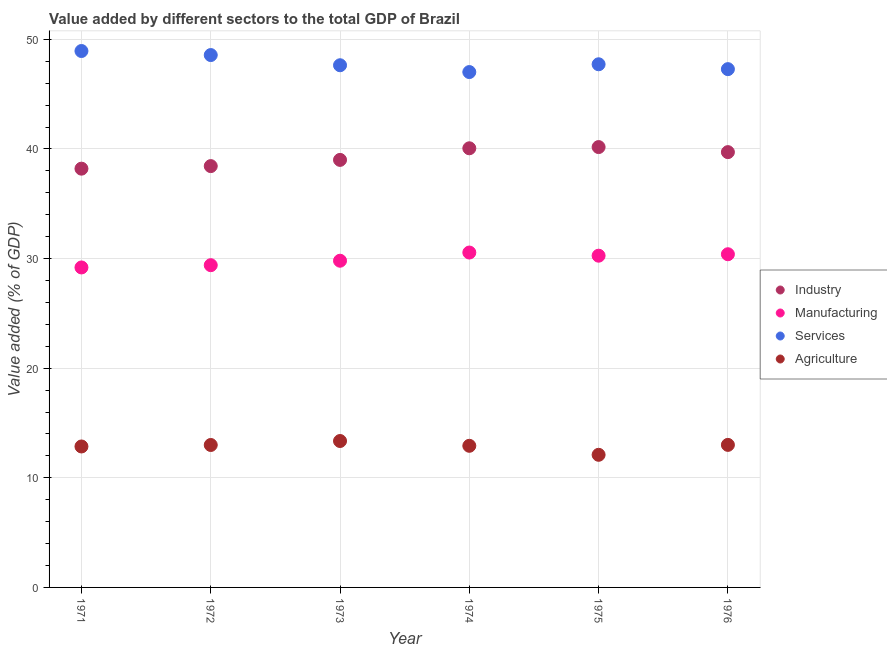How many different coloured dotlines are there?
Your answer should be very brief. 4. What is the value added by industrial sector in 1976?
Your response must be concise. 39.71. Across all years, what is the maximum value added by services sector?
Offer a terse response. 48.94. Across all years, what is the minimum value added by industrial sector?
Provide a short and direct response. 38.2. In which year was the value added by manufacturing sector maximum?
Your answer should be compact. 1974. In which year was the value added by services sector minimum?
Your answer should be very brief. 1974. What is the total value added by manufacturing sector in the graph?
Ensure brevity in your answer.  179.61. What is the difference between the value added by industrial sector in 1971 and that in 1976?
Provide a short and direct response. -1.51. What is the difference between the value added by services sector in 1972 and the value added by industrial sector in 1974?
Offer a very short reply. 8.51. What is the average value added by manufacturing sector per year?
Give a very brief answer. 29.93. In the year 1975, what is the difference between the value added by manufacturing sector and value added by agricultural sector?
Offer a terse response. 18.16. In how many years, is the value added by agricultural sector greater than 18 %?
Provide a short and direct response. 0. What is the ratio of the value added by industrial sector in 1974 to that in 1975?
Provide a succinct answer. 1. Is the value added by agricultural sector in 1971 less than that in 1972?
Provide a succinct answer. Yes. What is the difference between the highest and the second highest value added by industrial sector?
Give a very brief answer. 0.11. What is the difference between the highest and the lowest value added by services sector?
Ensure brevity in your answer.  1.92. Is it the case that in every year, the sum of the value added by agricultural sector and value added by industrial sector is greater than the sum of value added by manufacturing sector and value added by services sector?
Provide a short and direct response. No. Is the value added by services sector strictly less than the value added by manufacturing sector over the years?
Your answer should be very brief. No. How many dotlines are there?
Your response must be concise. 4. How many years are there in the graph?
Keep it short and to the point. 6. Does the graph contain grids?
Offer a very short reply. Yes. What is the title of the graph?
Your answer should be compact. Value added by different sectors to the total GDP of Brazil. Does "Other greenhouse gases" appear as one of the legend labels in the graph?
Offer a terse response. No. What is the label or title of the Y-axis?
Keep it short and to the point. Value added (% of GDP). What is the Value added (% of GDP) of Industry in 1971?
Ensure brevity in your answer.  38.2. What is the Value added (% of GDP) of Manufacturing in 1971?
Offer a very short reply. 29.19. What is the Value added (% of GDP) of Services in 1971?
Your answer should be compact. 48.94. What is the Value added (% of GDP) of Agriculture in 1971?
Your answer should be compact. 12.86. What is the Value added (% of GDP) of Industry in 1972?
Your answer should be very brief. 38.44. What is the Value added (% of GDP) in Manufacturing in 1972?
Provide a succinct answer. 29.4. What is the Value added (% of GDP) in Services in 1972?
Make the answer very short. 48.57. What is the Value added (% of GDP) in Agriculture in 1972?
Your answer should be compact. 12.99. What is the Value added (% of GDP) of Industry in 1973?
Make the answer very short. 39. What is the Value added (% of GDP) of Manufacturing in 1973?
Give a very brief answer. 29.81. What is the Value added (% of GDP) in Services in 1973?
Provide a succinct answer. 47.64. What is the Value added (% of GDP) of Agriculture in 1973?
Provide a succinct answer. 13.36. What is the Value added (% of GDP) of Industry in 1974?
Provide a short and direct response. 40.06. What is the Value added (% of GDP) of Manufacturing in 1974?
Give a very brief answer. 30.55. What is the Value added (% of GDP) in Services in 1974?
Give a very brief answer. 47.02. What is the Value added (% of GDP) in Agriculture in 1974?
Keep it short and to the point. 12.92. What is the Value added (% of GDP) of Industry in 1975?
Give a very brief answer. 40.17. What is the Value added (% of GDP) of Manufacturing in 1975?
Make the answer very short. 30.26. What is the Value added (% of GDP) of Services in 1975?
Give a very brief answer. 47.73. What is the Value added (% of GDP) in Agriculture in 1975?
Provide a succinct answer. 12.1. What is the Value added (% of GDP) of Industry in 1976?
Your response must be concise. 39.71. What is the Value added (% of GDP) of Manufacturing in 1976?
Offer a very short reply. 30.4. What is the Value added (% of GDP) in Services in 1976?
Your answer should be very brief. 47.28. What is the Value added (% of GDP) in Agriculture in 1976?
Ensure brevity in your answer.  13. Across all years, what is the maximum Value added (% of GDP) in Industry?
Provide a succinct answer. 40.17. Across all years, what is the maximum Value added (% of GDP) in Manufacturing?
Give a very brief answer. 30.55. Across all years, what is the maximum Value added (% of GDP) of Services?
Provide a short and direct response. 48.94. Across all years, what is the maximum Value added (% of GDP) in Agriculture?
Your answer should be very brief. 13.36. Across all years, what is the minimum Value added (% of GDP) in Industry?
Keep it short and to the point. 38.2. Across all years, what is the minimum Value added (% of GDP) of Manufacturing?
Your response must be concise. 29.19. Across all years, what is the minimum Value added (% of GDP) in Services?
Your response must be concise. 47.02. Across all years, what is the minimum Value added (% of GDP) in Agriculture?
Offer a very short reply. 12.1. What is the total Value added (% of GDP) of Industry in the graph?
Your answer should be compact. 235.59. What is the total Value added (% of GDP) in Manufacturing in the graph?
Give a very brief answer. 179.61. What is the total Value added (% of GDP) of Services in the graph?
Provide a succinct answer. 287.17. What is the total Value added (% of GDP) of Agriculture in the graph?
Give a very brief answer. 77.23. What is the difference between the Value added (% of GDP) of Industry in 1971 and that in 1972?
Keep it short and to the point. -0.23. What is the difference between the Value added (% of GDP) in Manufacturing in 1971 and that in 1972?
Your answer should be very brief. -0.21. What is the difference between the Value added (% of GDP) in Services in 1971 and that in 1972?
Your answer should be compact. 0.37. What is the difference between the Value added (% of GDP) of Agriculture in 1971 and that in 1972?
Provide a succinct answer. -0.14. What is the difference between the Value added (% of GDP) of Industry in 1971 and that in 1973?
Give a very brief answer. -0.8. What is the difference between the Value added (% of GDP) of Manufacturing in 1971 and that in 1973?
Your response must be concise. -0.61. What is the difference between the Value added (% of GDP) in Services in 1971 and that in 1973?
Your response must be concise. 1.3. What is the difference between the Value added (% of GDP) of Agriculture in 1971 and that in 1973?
Your response must be concise. -0.5. What is the difference between the Value added (% of GDP) of Industry in 1971 and that in 1974?
Your response must be concise. -1.86. What is the difference between the Value added (% of GDP) of Manufacturing in 1971 and that in 1974?
Keep it short and to the point. -1.36. What is the difference between the Value added (% of GDP) in Services in 1971 and that in 1974?
Provide a succinct answer. 1.92. What is the difference between the Value added (% of GDP) of Agriculture in 1971 and that in 1974?
Your answer should be compact. -0.06. What is the difference between the Value added (% of GDP) of Industry in 1971 and that in 1975?
Offer a terse response. -1.97. What is the difference between the Value added (% of GDP) in Manufacturing in 1971 and that in 1975?
Provide a succinct answer. -1.07. What is the difference between the Value added (% of GDP) of Services in 1971 and that in 1975?
Make the answer very short. 1.21. What is the difference between the Value added (% of GDP) in Agriculture in 1971 and that in 1975?
Ensure brevity in your answer.  0.76. What is the difference between the Value added (% of GDP) of Industry in 1971 and that in 1976?
Provide a short and direct response. -1.51. What is the difference between the Value added (% of GDP) in Manufacturing in 1971 and that in 1976?
Give a very brief answer. -1.21. What is the difference between the Value added (% of GDP) in Services in 1971 and that in 1976?
Your response must be concise. 1.65. What is the difference between the Value added (% of GDP) in Agriculture in 1971 and that in 1976?
Provide a short and direct response. -0.15. What is the difference between the Value added (% of GDP) of Industry in 1972 and that in 1973?
Provide a succinct answer. -0.57. What is the difference between the Value added (% of GDP) in Manufacturing in 1972 and that in 1973?
Ensure brevity in your answer.  -0.41. What is the difference between the Value added (% of GDP) of Services in 1972 and that in 1973?
Provide a succinct answer. 0.93. What is the difference between the Value added (% of GDP) in Agriculture in 1972 and that in 1973?
Your response must be concise. -0.36. What is the difference between the Value added (% of GDP) in Industry in 1972 and that in 1974?
Provide a succinct answer. -1.63. What is the difference between the Value added (% of GDP) of Manufacturing in 1972 and that in 1974?
Give a very brief answer. -1.15. What is the difference between the Value added (% of GDP) in Services in 1972 and that in 1974?
Offer a terse response. 1.55. What is the difference between the Value added (% of GDP) of Agriculture in 1972 and that in 1974?
Keep it short and to the point. 0.07. What is the difference between the Value added (% of GDP) of Industry in 1972 and that in 1975?
Ensure brevity in your answer.  -1.74. What is the difference between the Value added (% of GDP) of Manufacturing in 1972 and that in 1975?
Your answer should be compact. -0.87. What is the difference between the Value added (% of GDP) in Services in 1972 and that in 1975?
Provide a succinct answer. 0.84. What is the difference between the Value added (% of GDP) in Agriculture in 1972 and that in 1975?
Ensure brevity in your answer.  0.9. What is the difference between the Value added (% of GDP) in Industry in 1972 and that in 1976?
Your answer should be compact. -1.27. What is the difference between the Value added (% of GDP) in Manufacturing in 1972 and that in 1976?
Offer a terse response. -1. What is the difference between the Value added (% of GDP) of Services in 1972 and that in 1976?
Your answer should be compact. 1.28. What is the difference between the Value added (% of GDP) in Agriculture in 1972 and that in 1976?
Your answer should be very brief. -0.01. What is the difference between the Value added (% of GDP) of Industry in 1973 and that in 1974?
Provide a short and direct response. -1.06. What is the difference between the Value added (% of GDP) in Manufacturing in 1973 and that in 1974?
Your answer should be very brief. -0.75. What is the difference between the Value added (% of GDP) in Services in 1973 and that in 1974?
Offer a very short reply. 0.62. What is the difference between the Value added (% of GDP) in Agriculture in 1973 and that in 1974?
Give a very brief answer. 0.44. What is the difference between the Value added (% of GDP) in Industry in 1973 and that in 1975?
Provide a short and direct response. -1.17. What is the difference between the Value added (% of GDP) in Manufacturing in 1973 and that in 1975?
Your response must be concise. -0.46. What is the difference between the Value added (% of GDP) of Services in 1973 and that in 1975?
Make the answer very short. -0.09. What is the difference between the Value added (% of GDP) in Agriculture in 1973 and that in 1975?
Make the answer very short. 1.26. What is the difference between the Value added (% of GDP) in Industry in 1973 and that in 1976?
Give a very brief answer. -0.71. What is the difference between the Value added (% of GDP) of Manufacturing in 1973 and that in 1976?
Give a very brief answer. -0.59. What is the difference between the Value added (% of GDP) in Services in 1973 and that in 1976?
Make the answer very short. 0.36. What is the difference between the Value added (% of GDP) in Agriculture in 1973 and that in 1976?
Provide a succinct answer. 0.35. What is the difference between the Value added (% of GDP) of Industry in 1974 and that in 1975?
Make the answer very short. -0.11. What is the difference between the Value added (% of GDP) of Manufacturing in 1974 and that in 1975?
Keep it short and to the point. 0.29. What is the difference between the Value added (% of GDP) of Services in 1974 and that in 1975?
Ensure brevity in your answer.  -0.71. What is the difference between the Value added (% of GDP) of Agriculture in 1974 and that in 1975?
Keep it short and to the point. 0.82. What is the difference between the Value added (% of GDP) in Industry in 1974 and that in 1976?
Give a very brief answer. 0.35. What is the difference between the Value added (% of GDP) of Manufacturing in 1974 and that in 1976?
Your response must be concise. 0.16. What is the difference between the Value added (% of GDP) in Services in 1974 and that in 1976?
Offer a very short reply. -0.27. What is the difference between the Value added (% of GDP) in Agriculture in 1974 and that in 1976?
Your answer should be very brief. -0.08. What is the difference between the Value added (% of GDP) of Industry in 1975 and that in 1976?
Make the answer very short. 0.46. What is the difference between the Value added (% of GDP) of Manufacturing in 1975 and that in 1976?
Keep it short and to the point. -0.13. What is the difference between the Value added (% of GDP) of Services in 1975 and that in 1976?
Your response must be concise. 0.44. What is the difference between the Value added (% of GDP) in Agriculture in 1975 and that in 1976?
Your answer should be very brief. -0.91. What is the difference between the Value added (% of GDP) of Industry in 1971 and the Value added (% of GDP) of Manufacturing in 1972?
Your answer should be compact. 8.81. What is the difference between the Value added (% of GDP) of Industry in 1971 and the Value added (% of GDP) of Services in 1972?
Keep it short and to the point. -10.36. What is the difference between the Value added (% of GDP) in Industry in 1971 and the Value added (% of GDP) in Agriculture in 1972?
Provide a short and direct response. 25.21. What is the difference between the Value added (% of GDP) in Manufacturing in 1971 and the Value added (% of GDP) in Services in 1972?
Provide a short and direct response. -19.38. What is the difference between the Value added (% of GDP) of Manufacturing in 1971 and the Value added (% of GDP) of Agriculture in 1972?
Ensure brevity in your answer.  16.2. What is the difference between the Value added (% of GDP) of Services in 1971 and the Value added (% of GDP) of Agriculture in 1972?
Ensure brevity in your answer.  35.94. What is the difference between the Value added (% of GDP) in Industry in 1971 and the Value added (% of GDP) in Manufacturing in 1973?
Provide a short and direct response. 8.4. What is the difference between the Value added (% of GDP) in Industry in 1971 and the Value added (% of GDP) in Services in 1973?
Offer a very short reply. -9.43. What is the difference between the Value added (% of GDP) of Industry in 1971 and the Value added (% of GDP) of Agriculture in 1973?
Ensure brevity in your answer.  24.85. What is the difference between the Value added (% of GDP) in Manufacturing in 1971 and the Value added (% of GDP) in Services in 1973?
Offer a terse response. -18.45. What is the difference between the Value added (% of GDP) in Manufacturing in 1971 and the Value added (% of GDP) in Agriculture in 1973?
Provide a short and direct response. 15.83. What is the difference between the Value added (% of GDP) of Services in 1971 and the Value added (% of GDP) of Agriculture in 1973?
Provide a succinct answer. 35.58. What is the difference between the Value added (% of GDP) in Industry in 1971 and the Value added (% of GDP) in Manufacturing in 1974?
Keep it short and to the point. 7.65. What is the difference between the Value added (% of GDP) of Industry in 1971 and the Value added (% of GDP) of Services in 1974?
Make the answer very short. -8.81. What is the difference between the Value added (% of GDP) in Industry in 1971 and the Value added (% of GDP) in Agriculture in 1974?
Your answer should be compact. 25.28. What is the difference between the Value added (% of GDP) of Manufacturing in 1971 and the Value added (% of GDP) of Services in 1974?
Give a very brief answer. -17.83. What is the difference between the Value added (% of GDP) of Manufacturing in 1971 and the Value added (% of GDP) of Agriculture in 1974?
Offer a very short reply. 16.27. What is the difference between the Value added (% of GDP) of Services in 1971 and the Value added (% of GDP) of Agriculture in 1974?
Offer a very short reply. 36.02. What is the difference between the Value added (% of GDP) in Industry in 1971 and the Value added (% of GDP) in Manufacturing in 1975?
Offer a terse response. 7.94. What is the difference between the Value added (% of GDP) in Industry in 1971 and the Value added (% of GDP) in Services in 1975?
Offer a terse response. -9.52. What is the difference between the Value added (% of GDP) of Industry in 1971 and the Value added (% of GDP) of Agriculture in 1975?
Offer a very short reply. 26.1. What is the difference between the Value added (% of GDP) in Manufacturing in 1971 and the Value added (% of GDP) in Services in 1975?
Offer a terse response. -18.54. What is the difference between the Value added (% of GDP) of Manufacturing in 1971 and the Value added (% of GDP) of Agriculture in 1975?
Keep it short and to the point. 17.09. What is the difference between the Value added (% of GDP) of Services in 1971 and the Value added (% of GDP) of Agriculture in 1975?
Offer a very short reply. 36.84. What is the difference between the Value added (% of GDP) in Industry in 1971 and the Value added (% of GDP) in Manufacturing in 1976?
Give a very brief answer. 7.81. What is the difference between the Value added (% of GDP) of Industry in 1971 and the Value added (% of GDP) of Services in 1976?
Your answer should be very brief. -9.08. What is the difference between the Value added (% of GDP) of Industry in 1971 and the Value added (% of GDP) of Agriculture in 1976?
Keep it short and to the point. 25.2. What is the difference between the Value added (% of GDP) in Manufacturing in 1971 and the Value added (% of GDP) in Services in 1976?
Your answer should be compact. -18.09. What is the difference between the Value added (% of GDP) of Manufacturing in 1971 and the Value added (% of GDP) of Agriculture in 1976?
Offer a very short reply. 16.19. What is the difference between the Value added (% of GDP) in Services in 1971 and the Value added (% of GDP) in Agriculture in 1976?
Your response must be concise. 35.93. What is the difference between the Value added (% of GDP) in Industry in 1972 and the Value added (% of GDP) in Manufacturing in 1973?
Provide a succinct answer. 8.63. What is the difference between the Value added (% of GDP) of Industry in 1972 and the Value added (% of GDP) of Services in 1973?
Your answer should be very brief. -9.2. What is the difference between the Value added (% of GDP) in Industry in 1972 and the Value added (% of GDP) in Agriculture in 1973?
Your answer should be compact. 25.08. What is the difference between the Value added (% of GDP) in Manufacturing in 1972 and the Value added (% of GDP) in Services in 1973?
Your answer should be very brief. -18.24. What is the difference between the Value added (% of GDP) in Manufacturing in 1972 and the Value added (% of GDP) in Agriculture in 1973?
Provide a short and direct response. 16.04. What is the difference between the Value added (% of GDP) of Services in 1972 and the Value added (% of GDP) of Agriculture in 1973?
Your answer should be compact. 35.21. What is the difference between the Value added (% of GDP) of Industry in 1972 and the Value added (% of GDP) of Manufacturing in 1974?
Make the answer very short. 7.88. What is the difference between the Value added (% of GDP) in Industry in 1972 and the Value added (% of GDP) in Services in 1974?
Offer a terse response. -8.58. What is the difference between the Value added (% of GDP) of Industry in 1972 and the Value added (% of GDP) of Agriculture in 1974?
Your response must be concise. 25.52. What is the difference between the Value added (% of GDP) in Manufacturing in 1972 and the Value added (% of GDP) in Services in 1974?
Keep it short and to the point. -17.62. What is the difference between the Value added (% of GDP) of Manufacturing in 1972 and the Value added (% of GDP) of Agriculture in 1974?
Ensure brevity in your answer.  16.48. What is the difference between the Value added (% of GDP) in Services in 1972 and the Value added (% of GDP) in Agriculture in 1974?
Offer a very short reply. 35.65. What is the difference between the Value added (% of GDP) in Industry in 1972 and the Value added (% of GDP) in Manufacturing in 1975?
Make the answer very short. 8.17. What is the difference between the Value added (% of GDP) in Industry in 1972 and the Value added (% of GDP) in Services in 1975?
Give a very brief answer. -9.29. What is the difference between the Value added (% of GDP) of Industry in 1972 and the Value added (% of GDP) of Agriculture in 1975?
Provide a succinct answer. 26.34. What is the difference between the Value added (% of GDP) in Manufacturing in 1972 and the Value added (% of GDP) in Services in 1975?
Your answer should be very brief. -18.33. What is the difference between the Value added (% of GDP) in Manufacturing in 1972 and the Value added (% of GDP) in Agriculture in 1975?
Give a very brief answer. 17.3. What is the difference between the Value added (% of GDP) in Services in 1972 and the Value added (% of GDP) in Agriculture in 1975?
Provide a succinct answer. 36.47. What is the difference between the Value added (% of GDP) in Industry in 1972 and the Value added (% of GDP) in Manufacturing in 1976?
Provide a succinct answer. 8.04. What is the difference between the Value added (% of GDP) in Industry in 1972 and the Value added (% of GDP) in Services in 1976?
Provide a short and direct response. -8.85. What is the difference between the Value added (% of GDP) in Industry in 1972 and the Value added (% of GDP) in Agriculture in 1976?
Your response must be concise. 25.43. What is the difference between the Value added (% of GDP) in Manufacturing in 1972 and the Value added (% of GDP) in Services in 1976?
Keep it short and to the point. -17.89. What is the difference between the Value added (% of GDP) of Manufacturing in 1972 and the Value added (% of GDP) of Agriculture in 1976?
Make the answer very short. 16.39. What is the difference between the Value added (% of GDP) in Services in 1972 and the Value added (% of GDP) in Agriculture in 1976?
Provide a succinct answer. 35.56. What is the difference between the Value added (% of GDP) of Industry in 1973 and the Value added (% of GDP) of Manufacturing in 1974?
Offer a very short reply. 8.45. What is the difference between the Value added (% of GDP) in Industry in 1973 and the Value added (% of GDP) in Services in 1974?
Offer a terse response. -8.01. What is the difference between the Value added (% of GDP) in Industry in 1973 and the Value added (% of GDP) in Agriculture in 1974?
Your answer should be very brief. 26.08. What is the difference between the Value added (% of GDP) of Manufacturing in 1973 and the Value added (% of GDP) of Services in 1974?
Your answer should be very brief. -17.21. What is the difference between the Value added (% of GDP) in Manufacturing in 1973 and the Value added (% of GDP) in Agriculture in 1974?
Your answer should be very brief. 16.88. What is the difference between the Value added (% of GDP) of Services in 1973 and the Value added (% of GDP) of Agriculture in 1974?
Offer a very short reply. 34.72. What is the difference between the Value added (% of GDP) of Industry in 1973 and the Value added (% of GDP) of Manufacturing in 1975?
Make the answer very short. 8.74. What is the difference between the Value added (% of GDP) in Industry in 1973 and the Value added (% of GDP) in Services in 1975?
Your response must be concise. -8.72. What is the difference between the Value added (% of GDP) in Industry in 1973 and the Value added (% of GDP) in Agriculture in 1975?
Your response must be concise. 26.91. What is the difference between the Value added (% of GDP) of Manufacturing in 1973 and the Value added (% of GDP) of Services in 1975?
Your response must be concise. -17.92. What is the difference between the Value added (% of GDP) of Manufacturing in 1973 and the Value added (% of GDP) of Agriculture in 1975?
Ensure brevity in your answer.  17.71. What is the difference between the Value added (% of GDP) of Services in 1973 and the Value added (% of GDP) of Agriculture in 1975?
Offer a terse response. 35.54. What is the difference between the Value added (% of GDP) of Industry in 1973 and the Value added (% of GDP) of Manufacturing in 1976?
Keep it short and to the point. 8.61. What is the difference between the Value added (% of GDP) in Industry in 1973 and the Value added (% of GDP) in Services in 1976?
Provide a short and direct response. -8.28. What is the difference between the Value added (% of GDP) in Industry in 1973 and the Value added (% of GDP) in Agriculture in 1976?
Offer a very short reply. 26. What is the difference between the Value added (% of GDP) of Manufacturing in 1973 and the Value added (% of GDP) of Services in 1976?
Ensure brevity in your answer.  -17.48. What is the difference between the Value added (% of GDP) in Manufacturing in 1973 and the Value added (% of GDP) in Agriculture in 1976?
Your answer should be compact. 16.8. What is the difference between the Value added (% of GDP) of Services in 1973 and the Value added (% of GDP) of Agriculture in 1976?
Make the answer very short. 34.63. What is the difference between the Value added (% of GDP) in Industry in 1974 and the Value added (% of GDP) in Manufacturing in 1975?
Make the answer very short. 9.8. What is the difference between the Value added (% of GDP) in Industry in 1974 and the Value added (% of GDP) in Services in 1975?
Give a very brief answer. -7.66. What is the difference between the Value added (% of GDP) of Industry in 1974 and the Value added (% of GDP) of Agriculture in 1975?
Your response must be concise. 27.96. What is the difference between the Value added (% of GDP) in Manufacturing in 1974 and the Value added (% of GDP) in Services in 1975?
Offer a very short reply. -17.18. What is the difference between the Value added (% of GDP) of Manufacturing in 1974 and the Value added (% of GDP) of Agriculture in 1975?
Your response must be concise. 18.45. What is the difference between the Value added (% of GDP) of Services in 1974 and the Value added (% of GDP) of Agriculture in 1975?
Provide a short and direct response. 34.92. What is the difference between the Value added (% of GDP) in Industry in 1974 and the Value added (% of GDP) in Manufacturing in 1976?
Make the answer very short. 9.67. What is the difference between the Value added (% of GDP) of Industry in 1974 and the Value added (% of GDP) of Services in 1976?
Keep it short and to the point. -7.22. What is the difference between the Value added (% of GDP) of Industry in 1974 and the Value added (% of GDP) of Agriculture in 1976?
Your answer should be very brief. 27.06. What is the difference between the Value added (% of GDP) in Manufacturing in 1974 and the Value added (% of GDP) in Services in 1976?
Provide a succinct answer. -16.73. What is the difference between the Value added (% of GDP) in Manufacturing in 1974 and the Value added (% of GDP) in Agriculture in 1976?
Make the answer very short. 17.55. What is the difference between the Value added (% of GDP) of Services in 1974 and the Value added (% of GDP) of Agriculture in 1976?
Keep it short and to the point. 34.01. What is the difference between the Value added (% of GDP) in Industry in 1975 and the Value added (% of GDP) in Manufacturing in 1976?
Give a very brief answer. 9.78. What is the difference between the Value added (% of GDP) of Industry in 1975 and the Value added (% of GDP) of Services in 1976?
Your answer should be very brief. -7.11. What is the difference between the Value added (% of GDP) of Industry in 1975 and the Value added (% of GDP) of Agriculture in 1976?
Keep it short and to the point. 27.17. What is the difference between the Value added (% of GDP) of Manufacturing in 1975 and the Value added (% of GDP) of Services in 1976?
Your answer should be compact. -17.02. What is the difference between the Value added (% of GDP) in Manufacturing in 1975 and the Value added (% of GDP) in Agriculture in 1976?
Your answer should be very brief. 17.26. What is the difference between the Value added (% of GDP) of Services in 1975 and the Value added (% of GDP) of Agriculture in 1976?
Your answer should be very brief. 34.72. What is the average Value added (% of GDP) of Industry per year?
Provide a succinct answer. 39.27. What is the average Value added (% of GDP) in Manufacturing per year?
Keep it short and to the point. 29.93. What is the average Value added (% of GDP) of Services per year?
Your answer should be compact. 47.86. What is the average Value added (% of GDP) of Agriculture per year?
Your answer should be compact. 12.87. In the year 1971, what is the difference between the Value added (% of GDP) in Industry and Value added (% of GDP) in Manufacturing?
Give a very brief answer. 9.01. In the year 1971, what is the difference between the Value added (% of GDP) of Industry and Value added (% of GDP) of Services?
Your answer should be compact. -10.73. In the year 1971, what is the difference between the Value added (% of GDP) in Industry and Value added (% of GDP) in Agriculture?
Offer a terse response. 25.34. In the year 1971, what is the difference between the Value added (% of GDP) in Manufacturing and Value added (% of GDP) in Services?
Your answer should be very brief. -19.75. In the year 1971, what is the difference between the Value added (% of GDP) in Manufacturing and Value added (% of GDP) in Agriculture?
Give a very brief answer. 16.33. In the year 1971, what is the difference between the Value added (% of GDP) of Services and Value added (% of GDP) of Agriculture?
Offer a very short reply. 36.08. In the year 1972, what is the difference between the Value added (% of GDP) of Industry and Value added (% of GDP) of Manufacturing?
Keep it short and to the point. 9.04. In the year 1972, what is the difference between the Value added (% of GDP) in Industry and Value added (% of GDP) in Services?
Offer a terse response. -10.13. In the year 1972, what is the difference between the Value added (% of GDP) of Industry and Value added (% of GDP) of Agriculture?
Your response must be concise. 25.44. In the year 1972, what is the difference between the Value added (% of GDP) of Manufacturing and Value added (% of GDP) of Services?
Give a very brief answer. -19.17. In the year 1972, what is the difference between the Value added (% of GDP) of Manufacturing and Value added (% of GDP) of Agriculture?
Offer a terse response. 16.4. In the year 1972, what is the difference between the Value added (% of GDP) of Services and Value added (% of GDP) of Agriculture?
Make the answer very short. 35.57. In the year 1973, what is the difference between the Value added (% of GDP) of Industry and Value added (% of GDP) of Manufacturing?
Give a very brief answer. 9.2. In the year 1973, what is the difference between the Value added (% of GDP) of Industry and Value added (% of GDP) of Services?
Your response must be concise. -8.63. In the year 1973, what is the difference between the Value added (% of GDP) in Industry and Value added (% of GDP) in Agriculture?
Offer a very short reply. 25.65. In the year 1973, what is the difference between the Value added (% of GDP) of Manufacturing and Value added (% of GDP) of Services?
Keep it short and to the point. -17.83. In the year 1973, what is the difference between the Value added (% of GDP) in Manufacturing and Value added (% of GDP) in Agriculture?
Provide a succinct answer. 16.45. In the year 1973, what is the difference between the Value added (% of GDP) in Services and Value added (% of GDP) in Agriculture?
Offer a very short reply. 34.28. In the year 1974, what is the difference between the Value added (% of GDP) of Industry and Value added (% of GDP) of Manufacturing?
Your answer should be very brief. 9.51. In the year 1974, what is the difference between the Value added (% of GDP) in Industry and Value added (% of GDP) in Services?
Provide a short and direct response. -6.95. In the year 1974, what is the difference between the Value added (% of GDP) of Industry and Value added (% of GDP) of Agriculture?
Offer a very short reply. 27.14. In the year 1974, what is the difference between the Value added (% of GDP) in Manufacturing and Value added (% of GDP) in Services?
Give a very brief answer. -16.46. In the year 1974, what is the difference between the Value added (% of GDP) of Manufacturing and Value added (% of GDP) of Agriculture?
Provide a succinct answer. 17.63. In the year 1974, what is the difference between the Value added (% of GDP) in Services and Value added (% of GDP) in Agriculture?
Offer a terse response. 34.1. In the year 1975, what is the difference between the Value added (% of GDP) in Industry and Value added (% of GDP) in Manufacturing?
Provide a short and direct response. 9.91. In the year 1975, what is the difference between the Value added (% of GDP) in Industry and Value added (% of GDP) in Services?
Your answer should be compact. -7.55. In the year 1975, what is the difference between the Value added (% of GDP) in Industry and Value added (% of GDP) in Agriculture?
Ensure brevity in your answer.  28.07. In the year 1975, what is the difference between the Value added (% of GDP) in Manufacturing and Value added (% of GDP) in Services?
Offer a terse response. -17.46. In the year 1975, what is the difference between the Value added (% of GDP) in Manufacturing and Value added (% of GDP) in Agriculture?
Your answer should be compact. 18.16. In the year 1975, what is the difference between the Value added (% of GDP) in Services and Value added (% of GDP) in Agriculture?
Offer a terse response. 35.63. In the year 1976, what is the difference between the Value added (% of GDP) in Industry and Value added (% of GDP) in Manufacturing?
Your answer should be very brief. 9.32. In the year 1976, what is the difference between the Value added (% of GDP) in Industry and Value added (% of GDP) in Services?
Provide a short and direct response. -7.57. In the year 1976, what is the difference between the Value added (% of GDP) in Industry and Value added (% of GDP) in Agriculture?
Offer a terse response. 26.71. In the year 1976, what is the difference between the Value added (% of GDP) of Manufacturing and Value added (% of GDP) of Services?
Keep it short and to the point. -16.89. In the year 1976, what is the difference between the Value added (% of GDP) of Manufacturing and Value added (% of GDP) of Agriculture?
Offer a very short reply. 17.39. In the year 1976, what is the difference between the Value added (% of GDP) of Services and Value added (% of GDP) of Agriculture?
Make the answer very short. 34.28. What is the ratio of the Value added (% of GDP) in Manufacturing in 1971 to that in 1972?
Your answer should be very brief. 0.99. What is the ratio of the Value added (% of GDP) in Services in 1971 to that in 1972?
Your response must be concise. 1.01. What is the ratio of the Value added (% of GDP) in Agriculture in 1971 to that in 1972?
Your answer should be compact. 0.99. What is the ratio of the Value added (% of GDP) of Industry in 1971 to that in 1973?
Offer a terse response. 0.98. What is the ratio of the Value added (% of GDP) in Manufacturing in 1971 to that in 1973?
Your answer should be very brief. 0.98. What is the ratio of the Value added (% of GDP) of Services in 1971 to that in 1973?
Make the answer very short. 1.03. What is the ratio of the Value added (% of GDP) in Agriculture in 1971 to that in 1973?
Your answer should be very brief. 0.96. What is the ratio of the Value added (% of GDP) of Industry in 1971 to that in 1974?
Make the answer very short. 0.95. What is the ratio of the Value added (% of GDP) in Manufacturing in 1971 to that in 1974?
Offer a very short reply. 0.96. What is the ratio of the Value added (% of GDP) of Services in 1971 to that in 1974?
Offer a very short reply. 1.04. What is the ratio of the Value added (% of GDP) of Agriculture in 1971 to that in 1974?
Give a very brief answer. 1. What is the ratio of the Value added (% of GDP) in Industry in 1971 to that in 1975?
Make the answer very short. 0.95. What is the ratio of the Value added (% of GDP) of Manufacturing in 1971 to that in 1975?
Make the answer very short. 0.96. What is the ratio of the Value added (% of GDP) of Services in 1971 to that in 1975?
Your response must be concise. 1.03. What is the ratio of the Value added (% of GDP) of Agriculture in 1971 to that in 1975?
Your answer should be very brief. 1.06. What is the ratio of the Value added (% of GDP) of Manufacturing in 1971 to that in 1976?
Provide a succinct answer. 0.96. What is the ratio of the Value added (% of GDP) in Services in 1971 to that in 1976?
Provide a succinct answer. 1.03. What is the ratio of the Value added (% of GDP) in Agriculture in 1971 to that in 1976?
Give a very brief answer. 0.99. What is the ratio of the Value added (% of GDP) in Industry in 1972 to that in 1973?
Keep it short and to the point. 0.99. What is the ratio of the Value added (% of GDP) of Manufacturing in 1972 to that in 1973?
Your response must be concise. 0.99. What is the ratio of the Value added (% of GDP) in Services in 1972 to that in 1973?
Ensure brevity in your answer.  1.02. What is the ratio of the Value added (% of GDP) in Agriculture in 1972 to that in 1973?
Provide a short and direct response. 0.97. What is the ratio of the Value added (% of GDP) in Industry in 1972 to that in 1974?
Give a very brief answer. 0.96. What is the ratio of the Value added (% of GDP) of Manufacturing in 1972 to that in 1974?
Keep it short and to the point. 0.96. What is the ratio of the Value added (% of GDP) in Services in 1972 to that in 1974?
Keep it short and to the point. 1.03. What is the ratio of the Value added (% of GDP) of Industry in 1972 to that in 1975?
Your response must be concise. 0.96. What is the ratio of the Value added (% of GDP) in Manufacturing in 1972 to that in 1975?
Your answer should be very brief. 0.97. What is the ratio of the Value added (% of GDP) in Services in 1972 to that in 1975?
Provide a short and direct response. 1.02. What is the ratio of the Value added (% of GDP) of Agriculture in 1972 to that in 1975?
Your response must be concise. 1.07. What is the ratio of the Value added (% of GDP) in Industry in 1972 to that in 1976?
Provide a short and direct response. 0.97. What is the ratio of the Value added (% of GDP) in Manufacturing in 1972 to that in 1976?
Provide a short and direct response. 0.97. What is the ratio of the Value added (% of GDP) of Services in 1972 to that in 1976?
Keep it short and to the point. 1.03. What is the ratio of the Value added (% of GDP) in Industry in 1973 to that in 1974?
Keep it short and to the point. 0.97. What is the ratio of the Value added (% of GDP) in Manufacturing in 1973 to that in 1974?
Your answer should be compact. 0.98. What is the ratio of the Value added (% of GDP) of Services in 1973 to that in 1974?
Provide a succinct answer. 1.01. What is the ratio of the Value added (% of GDP) of Agriculture in 1973 to that in 1974?
Give a very brief answer. 1.03. What is the ratio of the Value added (% of GDP) of Industry in 1973 to that in 1975?
Your response must be concise. 0.97. What is the ratio of the Value added (% of GDP) of Manufacturing in 1973 to that in 1975?
Your answer should be very brief. 0.98. What is the ratio of the Value added (% of GDP) of Agriculture in 1973 to that in 1975?
Provide a succinct answer. 1.1. What is the ratio of the Value added (% of GDP) in Industry in 1973 to that in 1976?
Your answer should be compact. 0.98. What is the ratio of the Value added (% of GDP) in Manufacturing in 1973 to that in 1976?
Provide a short and direct response. 0.98. What is the ratio of the Value added (% of GDP) of Services in 1973 to that in 1976?
Keep it short and to the point. 1.01. What is the ratio of the Value added (% of GDP) of Agriculture in 1973 to that in 1976?
Offer a very short reply. 1.03. What is the ratio of the Value added (% of GDP) in Industry in 1974 to that in 1975?
Your answer should be very brief. 1. What is the ratio of the Value added (% of GDP) of Manufacturing in 1974 to that in 1975?
Offer a terse response. 1.01. What is the ratio of the Value added (% of GDP) in Services in 1974 to that in 1975?
Provide a short and direct response. 0.99. What is the ratio of the Value added (% of GDP) in Agriculture in 1974 to that in 1975?
Provide a succinct answer. 1.07. What is the ratio of the Value added (% of GDP) of Industry in 1974 to that in 1976?
Make the answer very short. 1.01. What is the ratio of the Value added (% of GDP) in Manufacturing in 1974 to that in 1976?
Offer a very short reply. 1.01. What is the ratio of the Value added (% of GDP) in Services in 1974 to that in 1976?
Keep it short and to the point. 0.99. What is the ratio of the Value added (% of GDP) in Industry in 1975 to that in 1976?
Provide a succinct answer. 1.01. What is the ratio of the Value added (% of GDP) in Manufacturing in 1975 to that in 1976?
Give a very brief answer. 1. What is the ratio of the Value added (% of GDP) in Services in 1975 to that in 1976?
Offer a terse response. 1.01. What is the ratio of the Value added (% of GDP) of Agriculture in 1975 to that in 1976?
Your answer should be very brief. 0.93. What is the difference between the highest and the second highest Value added (% of GDP) of Manufacturing?
Make the answer very short. 0.16. What is the difference between the highest and the second highest Value added (% of GDP) in Services?
Ensure brevity in your answer.  0.37. What is the difference between the highest and the second highest Value added (% of GDP) in Agriculture?
Your answer should be compact. 0.35. What is the difference between the highest and the lowest Value added (% of GDP) of Industry?
Provide a succinct answer. 1.97. What is the difference between the highest and the lowest Value added (% of GDP) of Manufacturing?
Your answer should be compact. 1.36. What is the difference between the highest and the lowest Value added (% of GDP) of Services?
Provide a succinct answer. 1.92. What is the difference between the highest and the lowest Value added (% of GDP) of Agriculture?
Provide a succinct answer. 1.26. 